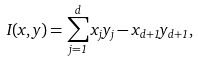Convert formula to latex. <formula><loc_0><loc_0><loc_500><loc_500>I ( x , y ) = \sum _ { j = 1 } ^ { d } x _ { j } y _ { j } - x _ { d + 1 } y _ { d + 1 } ,</formula> 